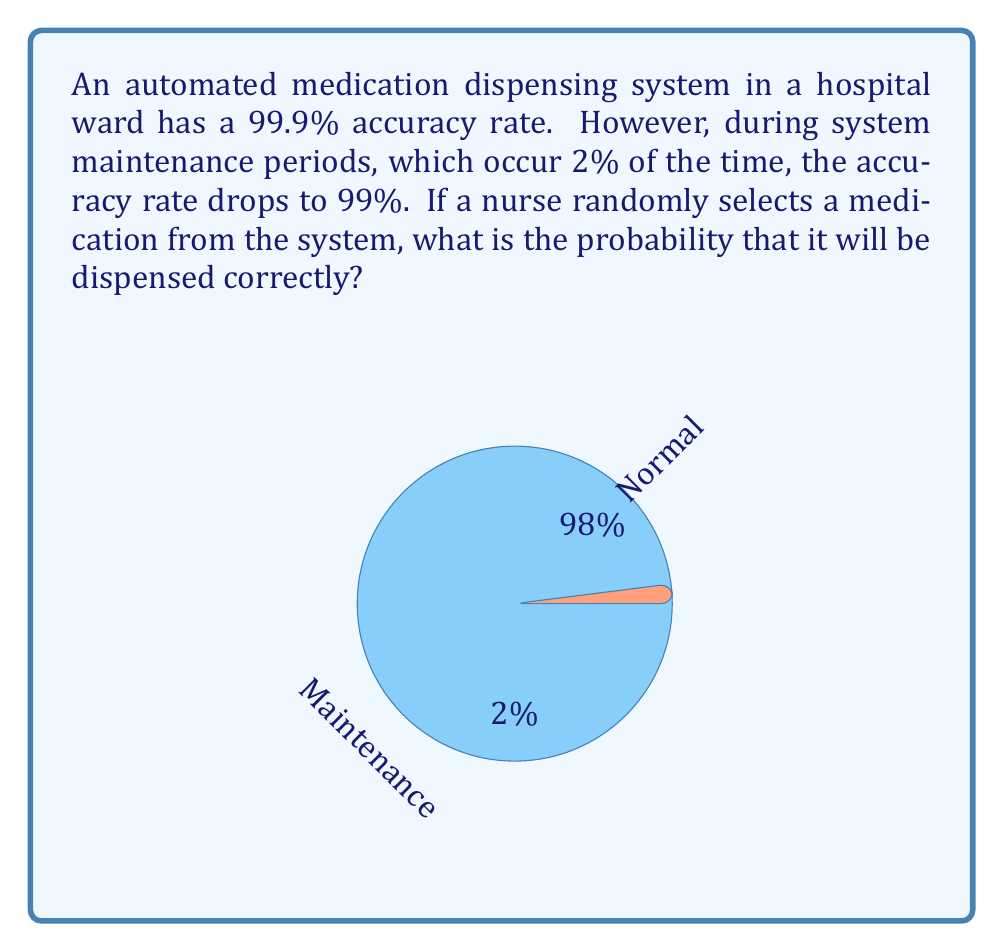Provide a solution to this math problem. Let's approach this step-by-step using the law of total probability:

1) Let A be the event that the medication is dispensed correctly.
2) Let N be the event that the system is in normal operation.
3) Let M be the event that the system is under maintenance.

We know:
- P(N) = 0.98 (98% of the time in normal operation)
- P(M) = 0.02 (2% of the time under maintenance)
- P(A|N) = 0.999 (99.9% accuracy during normal operation)
- P(A|M) = 0.99 (99% accuracy during maintenance)

Using the law of total probability:

$$P(A) = P(A|N) \cdot P(N) + P(A|M) \cdot P(M)$$

Substituting the values:

$$P(A) = 0.999 \cdot 0.98 + 0.99 \cdot 0.02$$

$$P(A) = 0.97902 + 0.0198$$

$$P(A) = 0.99882$$

Therefore, the probability that a randomly selected medication will be dispensed correctly is 0.99882 or 99.882%.
Answer: $0.99882$ or $99.882\%$ 